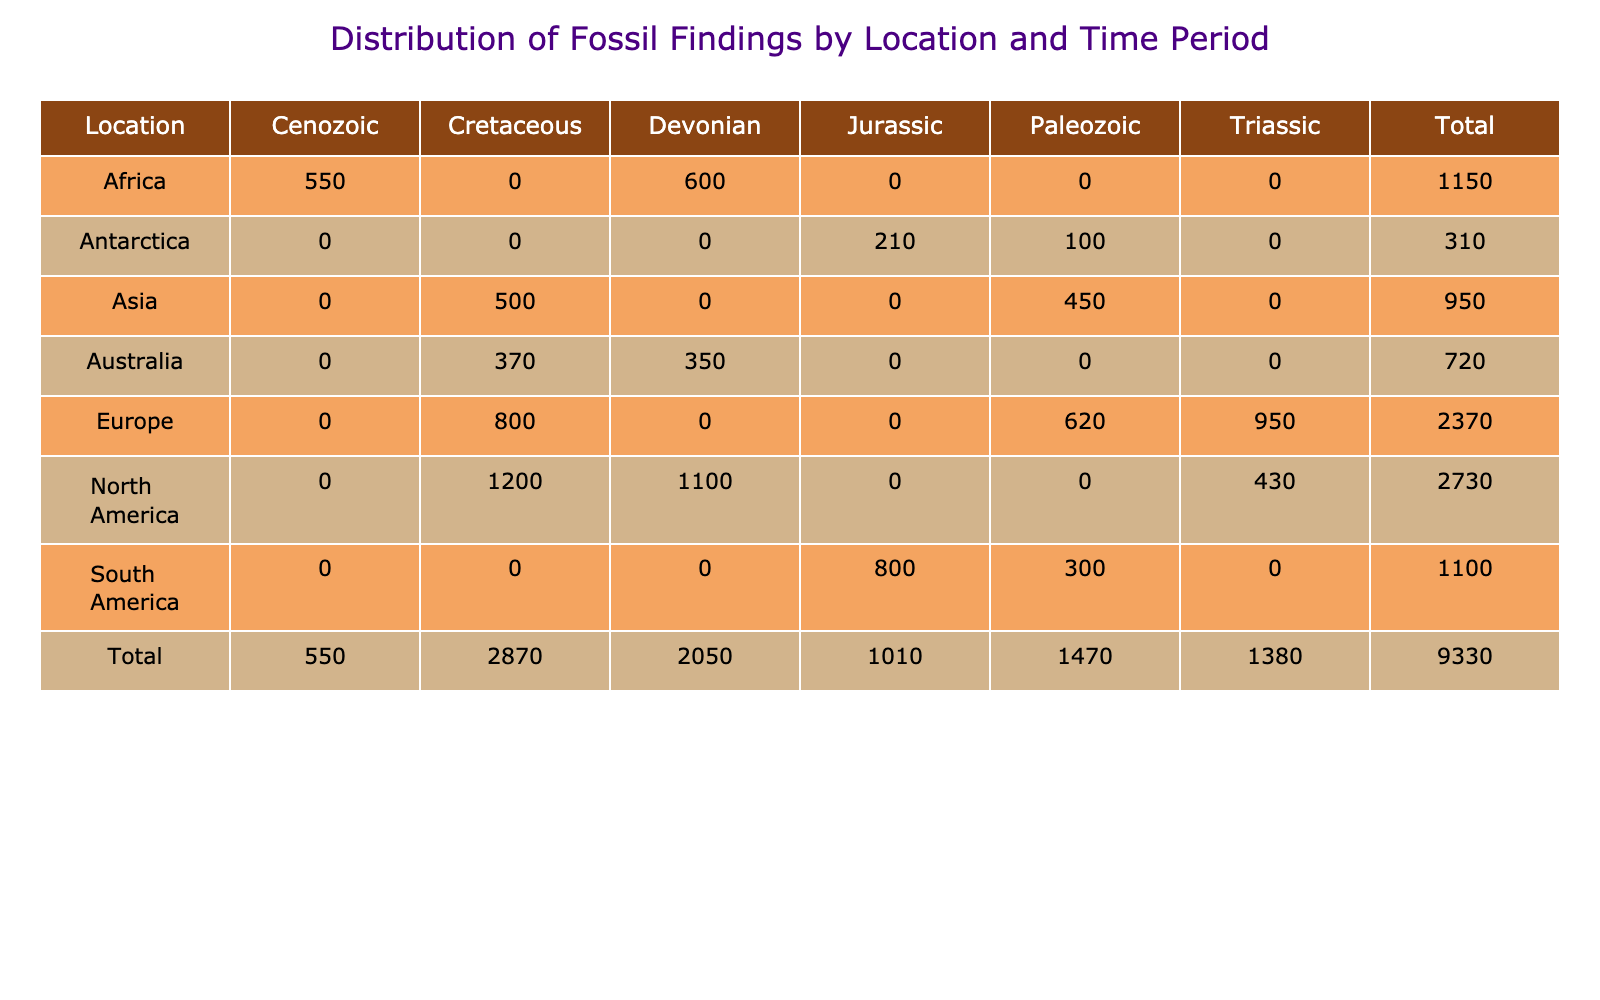What is the total number of fossils found in North America? To find the total number of fossils in North America, I look at the row corresponding to North America and sum the values from each time period: Cretaceous (1200) + Triassic (430) + Devonian (1100) = 2730.
Answer: 2730 Which time period has the highest number of fossil findings in South America? From the South America row, I can see the number of fossils for Jurassic (800) and Paleozoic (300). The highest is the Jurassic period with 800 fossils.
Answer: Jurassic What is the total number of fossils reported in Europe? To get the total for Europe, I sum the values from its row: Triassic (950) + Cretaceous (800) + Paleozoic (620) = 2370.
Answer: 2370 Is the number of fossils from Asia in the Cretaceous period greater than the number of fossils from Australia in the same period? In the Asia row for Cretaceous, there are 500 fossils, while in the Australia row for Cretaceous, there are 370 fossils. Since 500 is greater than 370, the answer is yes.
Answer: Yes What is the average number of fossils found in the Devonian period across all locations? I first gather the number of fossils for Devonian from each location: Africa (600) + Australia (350) + North America (1100) = 2050. There are three data points, so the average is 2050 / 3 = approximately 683.33.
Answer: 683.33 Which location has the least number of fossils overall? To determine this, I look at the total column and identify the lowest value. Upon checking, Antarctica has a total of 310 fossils, which is the least compared to the other locations.
Answer: Antarctica What is the difference in the number of fossils between Cretaceous and Triassic periods in North America? For North America, there are 1200 fossils in the Cretaceous and 430 in the Triassic. The difference is 1200 - 430 = 770.
Answer: 770 How many fossils were found across all locations during the Paleozoic period? I sum the values from the Paleozoic row: Asia (450) + South America (300) + Antarctica (100) + Europe (620) = 1470.
Answer: 1470 Is the combined total of fossils found in Africa greater than South America? For Africa, the total is Cenozoic (550) + Devonian (600) = 1150. For South America, it is Jurassic (800) + Paleozoic (300) = 1100. Since 1150 is greater than 1100, the answer is yes.
Answer: Yes 